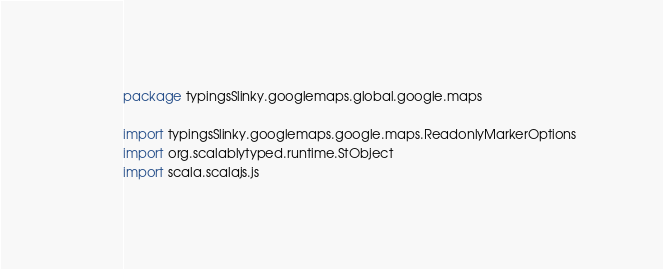Convert code to text. <code><loc_0><loc_0><loc_500><loc_500><_Scala_>package typingsSlinky.googlemaps.global.google.maps

import typingsSlinky.googlemaps.google.maps.ReadonlyMarkerOptions
import org.scalablytyped.runtime.StObject
import scala.scalajs.js</code> 